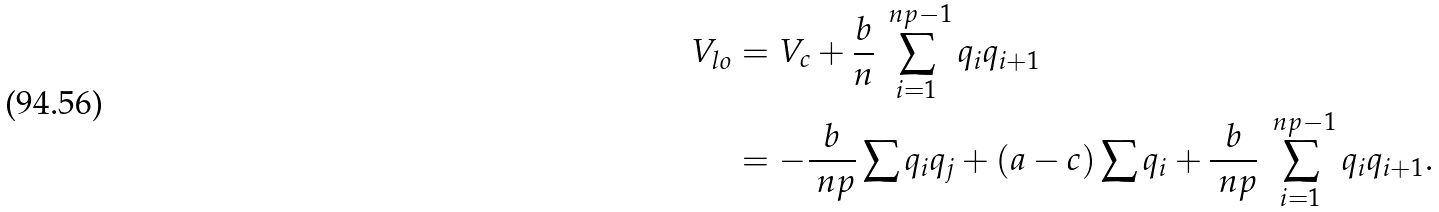Convert formula to latex. <formula><loc_0><loc_0><loc_500><loc_500>V _ { l o } & = V _ { c } + \frac { b } { n } \sum _ { i = 1 } ^ { \ n p - 1 } q _ { i } q _ { i + 1 } \\ & = - \frac { b } { \ n p } \sum q _ { i } q _ { j } + ( a - c ) \sum q _ { i } + \frac { b } { \ n p } \sum _ { i = 1 } ^ { \ n p - 1 } q _ { i } q _ { i + 1 } .</formula> 